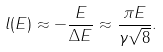<formula> <loc_0><loc_0><loc_500><loc_500>l ( E ) \approx - \frac { E } { \Delta E } \approx \frac { \pi E } { \gamma \sqrt { 8 } } .</formula> 